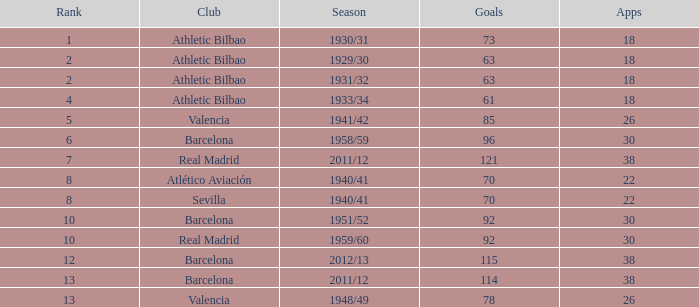How many apps when the rank was after 13 and having more than 73 goals? None. 